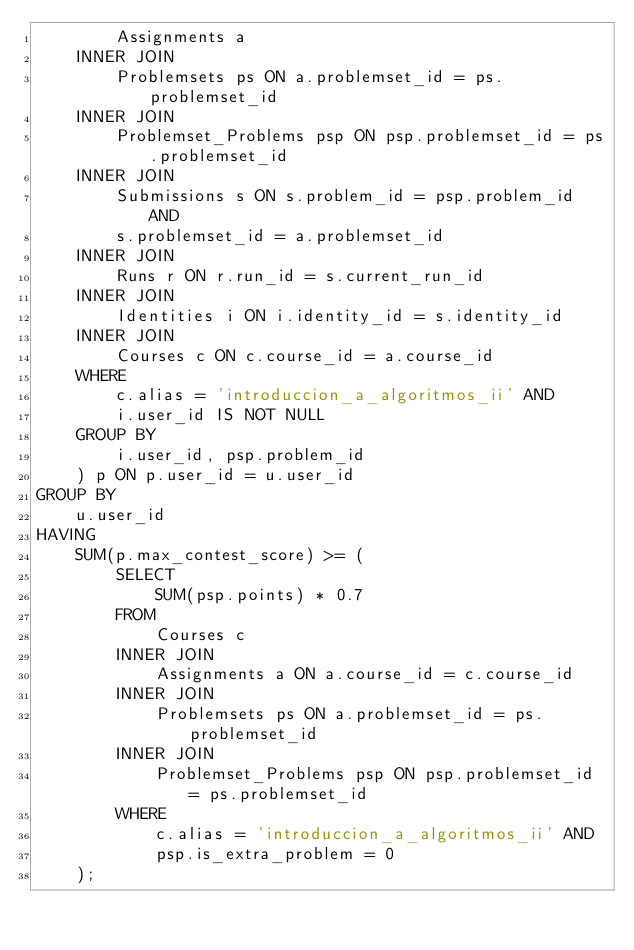<code> <loc_0><loc_0><loc_500><loc_500><_SQL_>        Assignments a
    INNER JOIN
        Problemsets ps ON a.problemset_id = ps.problemset_id
    INNER JOIN
        Problemset_Problems psp ON psp.problemset_id = ps.problemset_id
    INNER JOIN
        Submissions s ON s.problem_id = psp.problem_id AND
        s.problemset_id = a.problemset_id
    INNER JOIN
        Runs r ON r.run_id = s.current_run_id
    INNER JOIN
        Identities i ON i.identity_id = s.identity_id
    INNER JOIN
        Courses c ON c.course_id = a.course_id
    WHERE
        c.alias = 'introduccion_a_algoritmos_ii' AND
        i.user_id IS NOT NULL
    GROUP BY
        i.user_id, psp.problem_id
    ) p ON p.user_id = u.user_id
GROUP BY
    u.user_id
HAVING
    SUM(p.max_contest_score) >= (
        SELECT
            SUM(psp.points) * 0.7
        FROM
            Courses c
        INNER JOIN
            Assignments a ON a.course_id = c.course_id
        INNER JOIN
            Problemsets ps ON a.problemset_id = ps.problemset_id
        INNER JOIN
            Problemset_Problems psp ON psp.problemset_id = ps.problemset_id
        WHERE
            c.alias = 'introduccion_a_algoritmos_ii' AND
            psp.is_extra_problem = 0
    );</code> 